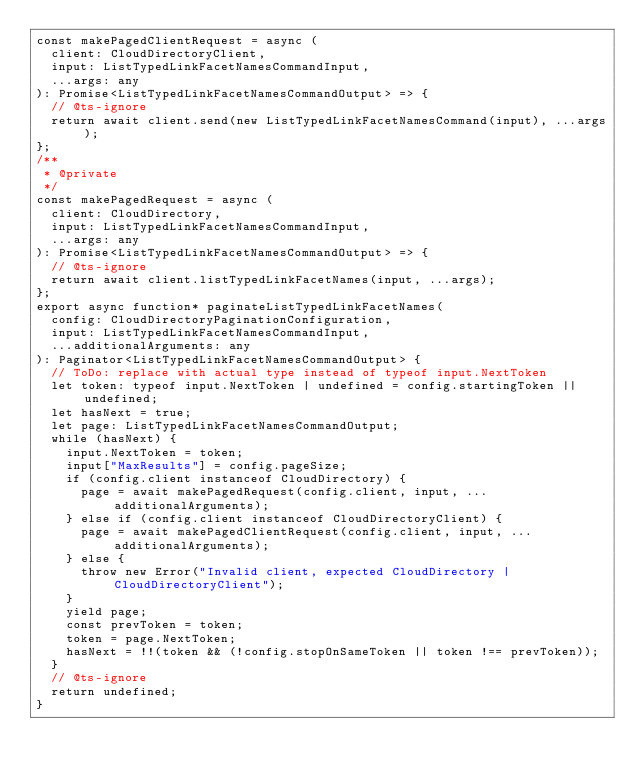Convert code to text. <code><loc_0><loc_0><loc_500><loc_500><_TypeScript_>const makePagedClientRequest = async (
  client: CloudDirectoryClient,
  input: ListTypedLinkFacetNamesCommandInput,
  ...args: any
): Promise<ListTypedLinkFacetNamesCommandOutput> => {
  // @ts-ignore
  return await client.send(new ListTypedLinkFacetNamesCommand(input), ...args);
};
/**
 * @private
 */
const makePagedRequest = async (
  client: CloudDirectory,
  input: ListTypedLinkFacetNamesCommandInput,
  ...args: any
): Promise<ListTypedLinkFacetNamesCommandOutput> => {
  // @ts-ignore
  return await client.listTypedLinkFacetNames(input, ...args);
};
export async function* paginateListTypedLinkFacetNames(
  config: CloudDirectoryPaginationConfiguration,
  input: ListTypedLinkFacetNamesCommandInput,
  ...additionalArguments: any
): Paginator<ListTypedLinkFacetNamesCommandOutput> {
  // ToDo: replace with actual type instead of typeof input.NextToken
  let token: typeof input.NextToken | undefined = config.startingToken || undefined;
  let hasNext = true;
  let page: ListTypedLinkFacetNamesCommandOutput;
  while (hasNext) {
    input.NextToken = token;
    input["MaxResults"] = config.pageSize;
    if (config.client instanceof CloudDirectory) {
      page = await makePagedRequest(config.client, input, ...additionalArguments);
    } else if (config.client instanceof CloudDirectoryClient) {
      page = await makePagedClientRequest(config.client, input, ...additionalArguments);
    } else {
      throw new Error("Invalid client, expected CloudDirectory | CloudDirectoryClient");
    }
    yield page;
    const prevToken = token;
    token = page.NextToken;
    hasNext = !!(token && (!config.stopOnSameToken || token !== prevToken));
  }
  // @ts-ignore
  return undefined;
}
</code> 